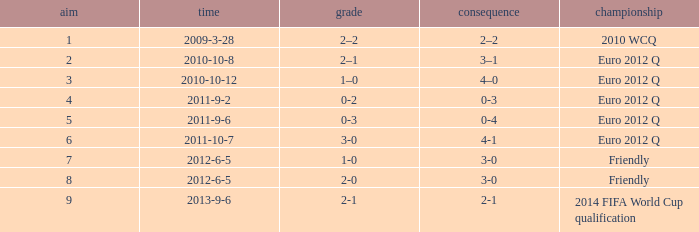How many goals when the score is 3-0 in the euro 2012 q? 1.0. 